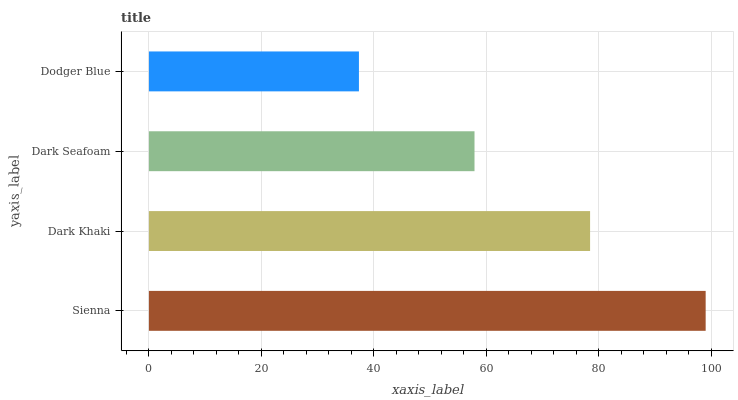Is Dodger Blue the minimum?
Answer yes or no. Yes. Is Sienna the maximum?
Answer yes or no. Yes. Is Dark Khaki the minimum?
Answer yes or no. No. Is Dark Khaki the maximum?
Answer yes or no. No. Is Sienna greater than Dark Khaki?
Answer yes or no. Yes. Is Dark Khaki less than Sienna?
Answer yes or no. Yes. Is Dark Khaki greater than Sienna?
Answer yes or no. No. Is Sienna less than Dark Khaki?
Answer yes or no. No. Is Dark Khaki the high median?
Answer yes or no. Yes. Is Dark Seafoam the low median?
Answer yes or no. Yes. Is Dodger Blue the high median?
Answer yes or no. No. Is Sienna the low median?
Answer yes or no. No. 